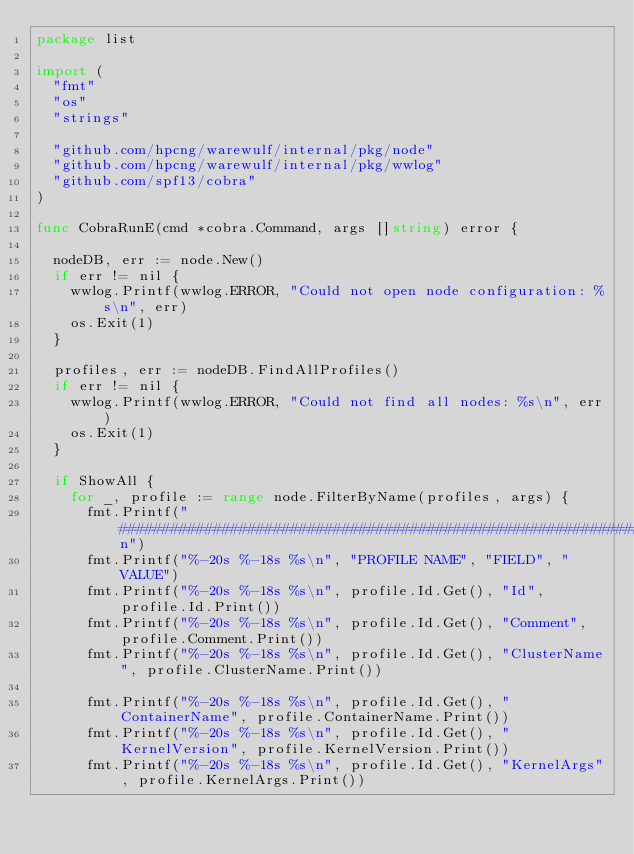Convert code to text. <code><loc_0><loc_0><loc_500><loc_500><_Go_>package list

import (
	"fmt"
	"os"
	"strings"

	"github.com/hpcng/warewulf/internal/pkg/node"
	"github.com/hpcng/warewulf/internal/pkg/wwlog"
	"github.com/spf13/cobra"
)

func CobraRunE(cmd *cobra.Command, args []string) error {

	nodeDB, err := node.New()
	if err != nil {
		wwlog.Printf(wwlog.ERROR, "Could not open node configuration: %s\n", err)
		os.Exit(1)
	}

	profiles, err := nodeDB.FindAllProfiles()
	if err != nil {
		wwlog.Printf(wwlog.ERROR, "Could not find all nodes: %s\n", err)
		os.Exit(1)
	}

	if ShowAll {
		for _, profile := range node.FilterByName(profiles, args) {
			fmt.Printf("################################################################################\n")
			fmt.Printf("%-20s %-18s %s\n", "PROFILE NAME", "FIELD", "VALUE")
			fmt.Printf("%-20s %-18s %s\n", profile.Id.Get(), "Id", profile.Id.Print())
			fmt.Printf("%-20s %-18s %s\n", profile.Id.Get(), "Comment", profile.Comment.Print())
			fmt.Printf("%-20s %-18s %s\n", profile.Id.Get(), "ClusterName", profile.ClusterName.Print())

			fmt.Printf("%-20s %-18s %s\n", profile.Id.Get(), "ContainerName", profile.ContainerName.Print())
			fmt.Printf("%-20s %-18s %s\n", profile.Id.Get(), "KernelVersion", profile.KernelVersion.Print())
			fmt.Printf("%-20s %-18s %s\n", profile.Id.Get(), "KernelArgs", profile.KernelArgs.Print())</code> 